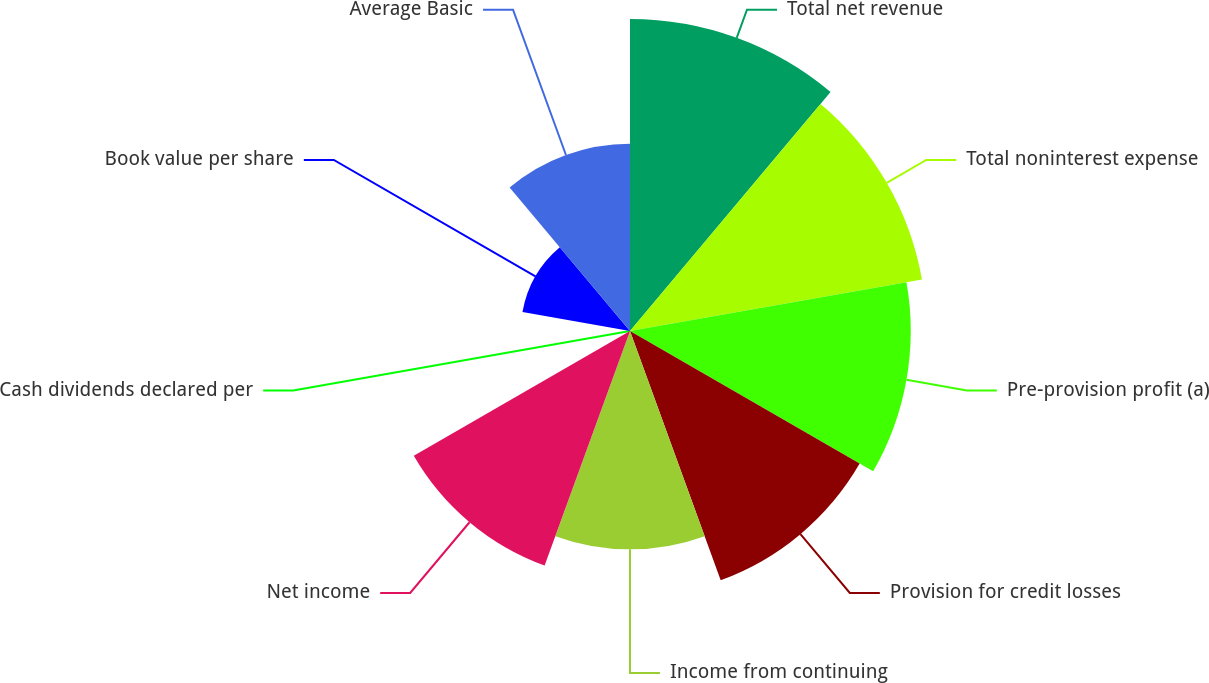Convert chart. <chart><loc_0><loc_0><loc_500><loc_500><pie_chart><fcel>Total net revenue<fcel>Total noninterest expense<fcel>Pre-provision profit (a)<fcel>Provision for credit losses<fcel>Income from continuing<fcel>Net income<fcel>Cash dividends declared per<fcel>Book value per share<fcel>Average Basic<nl><fcel>16.26%<fcel>15.45%<fcel>14.63%<fcel>13.82%<fcel>11.38%<fcel>13.01%<fcel>0.0%<fcel>5.69%<fcel>9.76%<nl></chart> 